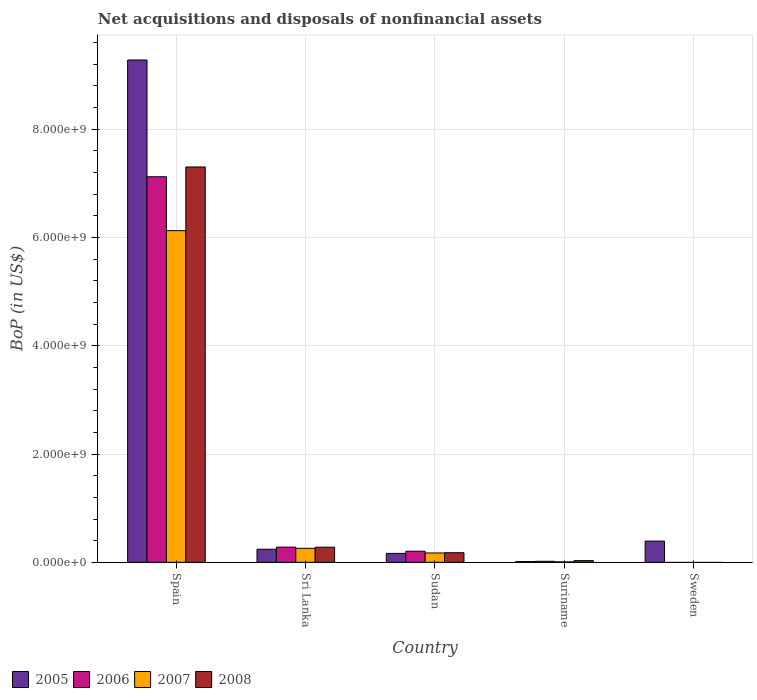How many different coloured bars are there?
Keep it short and to the point. 4. What is the label of the 1st group of bars from the left?
Provide a short and direct response. Spain. In how many cases, is the number of bars for a given country not equal to the number of legend labels?
Ensure brevity in your answer.  1. What is the Balance of Payments in 2006 in Sri Lanka?
Your answer should be compact. 2.81e+08. Across all countries, what is the maximum Balance of Payments in 2005?
Keep it short and to the point. 9.28e+09. Across all countries, what is the minimum Balance of Payments in 2005?
Make the answer very short. 1.45e+07. In which country was the Balance of Payments in 2007 maximum?
Provide a succinct answer. Spain. What is the total Balance of Payments in 2005 in the graph?
Provide a short and direct response. 1.01e+1. What is the difference between the Balance of Payments in 2008 in Sudan and that in Suriname?
Provide a short and direct response. 1.46e+08. What is the difference between the Balance of Payments in 2008 in Sweden and the Balance of Payments in 2005 in Sri Lanka?
Make the answer very short. -2.42e+08. What is the average Balance of Payments in 2007 per country?
Ensure brevity in your answer.  1.31e+09. What is the difference between the Balance of Payments of/in 2006 and Balance of Payments of/in 2005 in Spain?
Offer a very short reply. -2.16e+09. What is the ratio of the Balance of Payments in 2006 in Spain to that in Sri Lanka?
Give a very brief answer. 25.33. Is the difference between the Balance of Payments in 2006 in Spain and Sudan greater than the difference between the Balance of Payments in 2005 in Spain and Sudan?
Offer a very short reply. No. What is the difference between the highest and the second highest Balance of Payments in 2006?
Keep it short and to the point. -6.84e+09. What is the difference between the highest and the lowest Balance of Payments in 2007?
Provide a short and direct response. 6.12e+09. In how many countries, is the Balance of Payments in 2005 greater than the average Balance of Payments in 2005 taken over all countries?
Ensure brevity in your answer.  1. How many bars are there?
Make the answer very short. 17. What is the difference between two consecutive major ticks on the Y-axis?
Provide a short and direct response. 2.00e+09. Are the values on the major ticks of Y-axis written in scientific E-notation?
Ensure brevity in your answer.  Yes. Does the graph contain any zero values?
Give a very brief answer. Yes. Does the graph contain grids?
Offer a terse response. Yes. How many legend labels are there?
Your response must be concise. 4. How are the legend labels stacked?
Make the answer very short. Horizontal. What is the title of the graph?
Offer a terse response. Net acquisitions and disposals of nonfinancial assets. What is the label or title of the Y-axis?
Provide a short and direct response. BoP (in US$). What is the BoP (in US$) in 2005 in Spain?
Keep it short and to the point. 9.28e+09. What is the BoP (in US$) of 2006 in Spain?
Keep it short and to the point. 7.12e+09. What is the BoP (in US$) in 2007 in Spain?
Ensure brevity in your answer.  6.12e+09. What is the BoP (in US$) in 2008 in Spain?
Make the answer very short. 7.30e+09. What is the BoP (in US$) of 2005 in Sri Lanka?
Offer a very short reply. 2.42e+08. What is the BoP (in US$) of 2006 in Sri Lanka?
Offer a very short reply. 2.81e+08. What is the BoP (in US$) of 2007 in Sri Lanka?
Your answer should be compact. 2.59e+08. What is the BoP (in US$) of 2008 in Sri Lanka?
Offer a terse response. 2.80e+08. What is the BoP (in US$) of 2005 in Sudan?
Provide a succinct answer. 1.65e+08. What is the BoP (in US$) of 2006 in Sudan?
Offer a terse response. 2.05e+08. What is the BoP (in US$) of 2007 in Sudan?
Keep it short and to the point. 1.73e+08. What is the BoP (in US$) of 2008 in Sudan?
Your response must be concise. 1.77e+08. What is the BoP (in US$) of 2005 in Suriname?
Keep it short and to the point. 1.45e+07. What is the BoP (in US$) of 2006 in Suriname?
Give a very brief answer. 1.93e+07. What is the BoP (in US$) in 2007 in Suriname?
Ensure brevity in your answer.  8.10e+06. What is the BoP (in US$) in 2008 in Suriname?
Give a very brief answer. 3.19e+07. What is the BoP (in US$) in 2005 in Sweden?
Provide a short and direct response. 3.92e+08. What is the BoP (in US$) in 2006 in Sweden?
Offer a very short reply. 0. What is the BoP (in US$) in 2008 in Sweden?
Give a very brief answer. 0. Across all countries, what is the maximum BoP (in US$) of 2005?
Offer a terse response. 9.28e+09. Across all countries, what is the maximum BoP (in US$) of 2006?
Provide a short and direct response. 7.12e+09. Across all countries, what is the maximum BoP (in US$) of 2007?
Provide a succinct answer. 6.12e+09. Across all countries, what is the maximum BoP (in US$) in 2008?
Make the answer very short. 7.30e+09. Across all countries, what is the minimum BoP (in US$) in 2005?
Your answer should be very brief. 1.45e+07. Across all countries, what is the minimum BoP (in US$) in 2006?
Offer a very short reply. 0. Across all countries, what is the minimum BoP (in US$) of 2007?
Give a very brief answer. 0. Across all countries, what is the minimum BoP (in US$) of 2008?
Your answer should be compact. 0. What is the total BoP (in US$) in 2005 in the graph?
Provide a short and direct response. 1.01e+1. What is the total BoP (in US$) of 2006 in the graph?
Keep it short and to the point. 7.63e+09. What is the total BoP (in US$) of 2007 in the graph?
Provide a succinct answer. 6.57e+09. What is the total BoP (in US$) of 2008 in the graph?
Provide a succinct answer. 7.79e+09. What is the difference between the BoP (in US$) of 2005 in Spain and that in Sri Lanka?
Give a very brief answer. 9.03e+09. What is the difference between the BoP (in US$) of 2006 in Spain and that in Sri Lanka?
Provide a succinct answer. 6.84e+09. What is the difference between the BoP (in US$) in 2007 in Spain and that in Sri Lanka?
Your response must be concise. 5.87e+09. What is the difference between the BoP (in US$) of 2008 in Spain and that in Sri Lanka?
Your response must be concise. 7.02e+09. What is the difference between the BoP (in US$) in 2005 in Spain and that in Sudan?
Ensure brevity in your answer.  9.11e+09. What is the difference between the BoP (in US$) in 2006 in Spain and that in Sudan?
Your answer should be compact. 6.91e+09. What is the difference between the BoP (in US$) of 2007 in Spain and that in Sudan?
Your answer should be very brief. 5.95e+09. What is the difference between the BoP (in US$) in 2008 in Spain and that in Sudan?
Offer a terse response. 7.12e+09. What is the difference between the BoP (in US$) of 2005 in Spain and that in Suriname?
Keep it short and to the point. 9.26e+09. What is the difference between the BoP (in US$) in 2006 in Spain and that in Suriname?
Offer a very short reply. 7.10e+09. What is the difference between the BoP (in US$) of 2007 in Spain and that in Suriname?
Ensure brevity in your answer.  6.12e+09. What is the difference between the BoP (in US$) in 2008 in Spain and that in Suriname?
Give a very brief answer. 7.27e+09. What is the difference between the BoP (in US$) of 2005 in Spain and that in Sweden?
Give a very brief answer. 8.88e+09. What is the difference between the BoP (in US$) of 2005 in Sri Lanka and that in Sudan?
Provide a short and direct response. 7.67e+07. What is the difference between the BoP (in US$) in 2006 in Sri Lanka and that in Sudan?
Give a very brief answer. 7.58e+07. What is the difference between the BoP (in US$) in 2007 in Sri Lanka and that in Sudan?
Your answer should be compact. 8.58e+07. What is the difference between the BoP (in US$) of 2008 in Sri Lanka and that in Sudan?
Give a very brief answer. 1.02e+08. What is the difference between the BoP (in US$) of 2005 in Sri Lanka and that in Suriname?
Provide a succinct answer. 2.28e+08. What is the difference between the BoP (in US$) of 2006 in Sri Lanka and that in Suriname?
Your response must be concise. 2.62e+08. What is the difference between the BoP (in US$) of 2007 in Sri Lanka and that in Suriname?
Make the answer very short. 2.51e+08. What is the difference between the BoP (in US$) in 2008 in Sri Lanka and that in Suriname?
Keep it short and to the point. 2.48e+08. What is the difference between the BoP (in US$) in 2005 in Sri Lanka and that in Sweden?
Keep it short and to the point. -1.50e+08. What is the difference between the BoP (in US$) in 2005 in Sudan and that in Suriname?
Offer a terse response. 1.51e+08. What is the difference between the BoP (in US$) of 2006 in Sudan and that in Suriname?
Ensure brevity in your answer.  1.86e+08. What is the difference between the BoP (in US$) in 2007 in Sudan and that in Suriname?
Your answer should be compact. 1.65e+08. What is the difference between the BoP (in US$) in 2008 in Sudan and that in Suriname?
Ensure brevity in your answer.  1.46e+08. What is the difference between the BoP (in US$) of 2005 in Sudan and that in Sweden?
Your response must be concise. -2.27e+08. What is the difference between the BoP (in US$) of 2005 in Suriname and that in Sweden?
Keep it short and to the point. -3.78e+08. What is the difference between the BoP (in US$) of 2005 in Spain and the BoP (in US$) of 2006 in Sri Lanka?
Keep it short and to the point. 9.00e+09. What is the difference between the BoP (in US$) in 2005 in Spain and the BoP (in US$) in 2007 in Sri Lanka?
Ensure brevity in your answer.  9.02e+09. What is the difference between the BoP (in US$) of 2005 in Spain and the BoP (in US$) of 2008 in Sri Lanka?
Offer a very short reply. 9.00e+09. What is the difference between the BoP (in US$) in 2006 in Spain and the BoP (in US$) in 2007 in Sri Lanka?
Provide a succinct answer. 6.86e+09. What is the difference between the BoP (in US$) of 2006 in Spain and the BoP (in US$) of 2008 in Sri Lanka?
Your response must be concise. 6.84e+09. What is the difference between the BoP (in US$) of 2007 in Spain and the BoP (in US$) of 2008 in Sri Lanka?
Ensure brevity in your answer.  5.85e+09. What is the difference between the BoP (in US$) of 2005 in Spain and the BoP (in US$) of 2006 in Sudan?
Your answer should be very brief. 9.07e+09. What is the difference between the BoP (in US$) in 2005 in Spain and the BoP (in US$) in 2007 in Sudan?
Provide a short and direct response. 9.10e+09. What is the difference between the BoP (in US$) in 2005 in Spain and the BoP (in US$) in 2008 in Sudan?
Offer a very short reply. 9.10e+09. What is the difference between the BoP (in US$) in 2006 in Spain and the BoP (in US$) in 2007 in Sudan?
Give a very brief answer. 6.95e+09. What is the difference between the BoP (in US$) of 2006 in Spain and the BoP (in US$) of 2008 in Sudan?
Provide a succinct answer. 6.94e+09. What is the difference between the BoP (in US$) in 2007 in Spain and the BoP (in US$) in 2008 in Sudan?
Make the answer very short. 5.95e+09. What is the difference between the BoP (in US$) of 2005 in Spain and the BoP (in US$) of 2006 in Suriname?
Your answer should be compact. 9.26e+09. What is the difference between the BoP (in US$) of 2005 in Spain and the BoP (in US$) of 2007 in Suriname?
Your answer should be very brief. 9.27e+09. What is the difference between the BoP (in US$) in 2005 in Spain and the BoP (in US$) in 2008 in Suriname?
Give a very brief answer. 9.24e+09. What is the difference between the BoP (in US$) of 2006 in Spain and the BoP (in US$) of 2007 in Suriname?
Give a very brief answer. 7.11e+09. What is the difference between the BoP (in US$) in 2006 in Spain and the BoP (in US$) in 2008 in Suriname?
Make the answer very short. 7.09e+09. What is the difference between the BoP (in US$) in 2007 in Spain and the BoP (in US$) in 2008 in Suriname?
Provide a short and direct response. 6.09e+09. What is the difference between the BoP (in US$) in 2005 in Sri Lanka and the BoP (in US$) in 2006 in Sudan?
Offer a very short reply. 3.67e+07. What is the difference between the BoP (in US$) of 2005 in Sri Lanka and the BoP (in US$) of 2007 in Sudan?
Keep it short and to the point. 6.88e+07. What is the difference between the BoP (in US$) in 2005 in Sri Lanka and the BoP (in US$) in 2008 in Sudan?
Offer a terse response. 6.45e+07. What is the difference between the BoP (in US$) in 2006 in Sri Lanka and the BoP (in US$) in 2007 in Sudan?
Your response must be concise. 1.08e+08. What is the difference between the BoP (in US$) of 2006 in Sri Lanka and the BoP (in US$) of 2008 in Sudan?
Provide a succinct answer. 1.04e+08. What is the difference between the BoP (in US$) in 2007 in Sri Lanka and the BoP (in US$) in 2008 in Sudan?
Make the answer very short. 8.16e+07. What is the difference between the BoP (in US$) of 2005 in Sri Lanka and the BoP (in US$) of 2006 in Suriname?
Your answer should be compact. 2.23e+08. What is the difference between the BoP (in US$) of 2005 in Sri Lanka and the BoP (in US$) of 2007 in Suriname?
Provide a short and direct response. 2.34e+08. What is the difference between the BoP (in US$) in 2005 in Sri Lanka and the BoP (in US$) in 2008 in Suriname?
Ensure brevity in your answer.  2.10e+08. What is the difference between the BoP (in US$) in 2006 in Sri Lanka and the BoP (in US$) in 2007 in Suriname?
Make the answer very short. 2.73e+08. What is the difference between the BoP (in US$) in 2006 in Sri Lanka and the BoP (in US$) in 2008 in Suriname?
Make the answer very short. 2.49e+08. What is the difference between the BoP (in US$) of 2007 in Sri Lanka and the BoP (in US$) of 2008 in Suriname?
Provide a short and direct response. 2.27e+08. What is the difference between the BoP (in US$) in 2005 in Sudan and the BoP (in US$) in 2006 in Suriname?
Offer a very short reply. 1.46e+08. What is the difference between the BoP (in US$) in 2005 in Sudan and the BoP (in US$) in 2007 in Suriname?
Offer a terse response. 1.57e+08. What is the difference between the BoP (in US$) of 2005 in Sudan and the BoP (in US$) of 2008 in Suriname?
Provide a short and direct response. 1.33e+08. What is the difference between the BoP (in US$) of 2006 in Sudan and the BoP (in US$) of 2007 in Suriname?
Ensure brevity in your answer.  1.97e+08. What is the difference between the BoP (in US$) of 2006 in Sudan and the BoP (in US$) of 2008 in Suriname?
Your answer should be very brief. 1.73e+08. What is the difference between the BoP (in US$) in 2007 in Sudan and the BoP (in US$) in 2008 in Suriname?
Your answer should be very brief. 1.41e+08. What is the average BoP (in US$) in 2005 per country?
Offer a very short reply. 2.02e+09. What is the average BoP (in US$) in 2006 per country?
Provide a short and direct response. 1.53e+09. What is the average BoP (in US$) in 2007 per country?
Give a very brief answer. 1.31e+09. What is the average BoP (in US$) in 2008 per country?
Ensure brevity in your answer.  1.56e+09. What is the difference between the BoP (in US$) of 2005 and BoP (in US$) of 2006 in Spain?
Give a very brief answer. 2.16e+09. What is the difference between the BoP (in US$) in 2005 and BoP (in US$) in 2007 in Spain?
Give a very brief answer. 3.15e+09. What is the difference between the BoP (in US$) of 2005 and BoP (in US$) of 2008 in Spain?
Your answer should be very brief. 1.98e+09. What is the difference between the BoP (in US$) in 2006 and BoP (in US$) in 2007 in Spain?
Your answer should be very brief. 9.95e+08. What is the difference between the BoP (in US$) in 2006 and BoP (in US$) in 2008 in Spain?
Your answer should be compact. -1.81e+08. What is the difference between the BoP (in US$) of 2007 and BoP (in US$) of 2008 in Spain?
Your answer should be very brief. -1.18e+09. What is the difference between the BoP (in US$) of 2005 and BoP (in US$) of 2006 in Sri Lanka?
Give a very brief answer. -3.91e+07. What is the difference between the BoP (in US$) of 2005 and BoP (in US$) of 2007 in Sri Lanka?
Keep it short and to the point. -1.70e+07. What is the difference between the BoP (in US$) of 2005 and BoP (in US$) of 2008 in Sri Lanka?
Provide a short and direct response. -3.77e+07. What is the difference between the BoP (in US$) in 2006 and BoP (in US$) in 2007 in Sri Lanka?
Offer a very short reply. 2.20e+07. What is the difference between the BoP (in US$) of 2006 and BoP (in US$) of 2008 in Sri Lanka?
Offer a very short reply. 1.40e+06. What is the difference between the BoP (in US$) of 2007 and BoP (in US$) of 2008 in Sri Lanka?
Keep it short and to the point. -2.06e+07. What is the difference between the BoP (in US$) in 2005 and BoP (in US$) in 2006 in Sudan?
Make the answer very short. -4.00e+07. What is the difference between the BoP (in US$) of 2005 and BoP (in US$) of 2007 in Sudan?
Offer a very short reply. -7.94e+06. What is the difference between the BoP (in US$) of 2005 and BoP (in US$) of 2008 in Sudan?
Ensure brevity in your answer.  -1.22e+07. What is the difference between the BoP (in US$) in 2006 and BoP (in US$) in 2007 in Sudan?
Offer a very short reply. 3.21e+07. What is the difference between the BoP (in US$) of 2006 and BoP (in US$) of 2008 in Sudan?
Provide a short and direct response. 2.78e+07. What is the difference between the BoP (in US$) of 2007 and BoP (in US$) of 2008 in Sudan?
Give a very brief answer. -4.24e+06. What is the difference between the BoP (in US$) of 2005 and BoP (in US$) of 2006 in Suriname?
Give a very brief answer. -4.80e+06. What is the difference between the BoP (in US$) in 2005 and BoP (in US$) in 2007 in Suriname?
Your response must be concise. 6.40e+06. What is the difference between the BoP (in US$) of 2005 and BoP (in US$) of 2008 in Suriname?
Make the answer very short. -1.74e+07. What is the difference between the BoP (in US$) of 2006 and BoP (in US$) of 2007 in Suriname?
Your answer should be compact. 1.12e+07. What is the difference between the BoP (in US$) of 2006 and BoP (in US$) of 2008 in Suriname?
Provide a short and direct response. -1.26e+07. What is the difference between the BoP (in US$) of 2007 and BoP (in US$) of 2008 in Suriname?
Provide a succinct answer. -2.38e+07. What is the ratio of the BoP (in US$) of 2005 in Spain to that in Sri Lanka?
Offer a terse response. 38.33. What is the ratio of the BoP (in US$) of 2006 in Spain to that in Sri Lanka?
Ensure brevity in your answer.  25.33. What is the ratio of the BoP (in US$) in 2007 in Spain to that in Sri Lanka?
Give a very brief answer. 23.64. What is the ratio of the BoP (in US$) of 2008 in Spain to that in Sri Lanka?
Your response must be concise. 26.1. What is the ratio of the BoP (in US$) in 2005 in Spain to that in Sudan?
Provide a short and direct response. 56.12. What is the ratio of the BoP (in US$) in 2006 in Spain to that in Sudan?
Give a very brief answer. 34.68. What is the ratio of the BoP (in US$) in 2007 in Spain to that in Sudan?
Your answer should be compact. 35.36. What is the ratio of the BoP (in US$) of 2008 in Spain to that in Sudan?
Provide a short and direct response. 41.14. What is the ratio of the BoP (in US$) of 2005 in Spain to that in Suriname?
Ensure brevity in your answer.  639.74. What is the ratio of the BoP (in US$) in 2006 in Spain to that in Suriname?
Offer a very short reply. 368.91. What is the ratio of the BoP (in US$) of 2007 in Spain to that in Suriname?
Provide a succinct answer. 756.16. What is the ratio of the BoP (in US$) in 2008 in Spain to that in Suriname?
Provide a short and direct response. 228.86. What is the ratio of the BoP (in US$) in 2005 in Spain to that in Sweden?
Ensure brevity in your answer.  23.65. What is the ratio of the BoP (in US$) in 2005 in Sri Lanka to that in Sudan?
Offer a very short reply. 1.46. What is the ratio of the BoP (in US$) in 2006 in Sri Lanka to that in Sudan?
Give a very brief answer. 1.37. What is the ratio of the BoP (in US$) of 2007 in Sri Lanka to that in Sudan?
Offer a terse response. 1.5. What is the ratio of the BoP (in US$) in 2008 in Sri Lanka to that in Sudan?
Provide a short and direct response. 1.58. What is the ratio of the BoP (in US$) in 2005 in Sri Lanka to that in Suriname?
Your answer should be compact. 16.69. What is the ratio of the BoP (in US$) of 2006 in Sri Lanka to that in Suriname?
Provide a short and direct response. 14.56. What is the ratio of the BoP (in US$) in 2007 in Sri Lanka to that in Suriname?
Offer a very short reply. 31.98. What is the ratio of the BoP (in US$) in 2008 in Sri Lanka to that in Suriname?
Ensure brevity in your answer.  8.77. What is the ratio of the BoP (in US$) in 2005 in Sri Lanka to that in Sweden?
Offer a very short reply. 0.62. What is the ratio of the BoP (in US$) in 2005 in Sudan to that in Suriname?
Give a very brief answer. 11.4. What is the ratio of the BoP (in US$) in 2006 in Sudan to that in Suriname?
Give a very brief answer. 10.64. What is the ratio of the BoP (in US$) of 2007 in Sudan to that in Suriname?
Make the answer very short. 21.39. What is the ratio of the BoP (in US$) in 2008 in Sudan to that in Suriname?
Offer a terse response. 5.56. What is the ratio of the BoP (in US$) of 2005 in Sudan to that in Sweden?
Your answer should be very brief. 0.42. What is the ratio of the BoP (in US$) of 2005 in Suriname to that in Sweden?
Provide a short and direct response. 0.04. What is the difference between the highest and the second highest BoP (in US$) of 2005?
Provide a succinct answer. 8.88e+09. What is the difference between the highest and the second highest BoP (in US$) in 2006?
Offer a very short reply. 6.84e+09. What is the difference between the highest and the second highest BoP (in US$) of 2007?
Ensure brevity in your answer.  5.87e+09. What is the difference between the highest and the second highest BoP (in US$) of 2008?
Offer a terse response. 7.02e+09. What is the difference between the highest and the lowest BoP (in US$) of 2005?
Provide a short and direct response. 9.26e+09. What is the difference between the highest and the lowest BoP (in US$) in 2006?
Your answer should be very brief. 7.12e+09. What is the difference between the highest and the lowest BoP (in US$) in 2007?
Make the answer very short. 6.12e+09. What is the difference between the highest and the lowest BoP (in US$) of 2008?
Offer a terse response. 7.30e+09. 